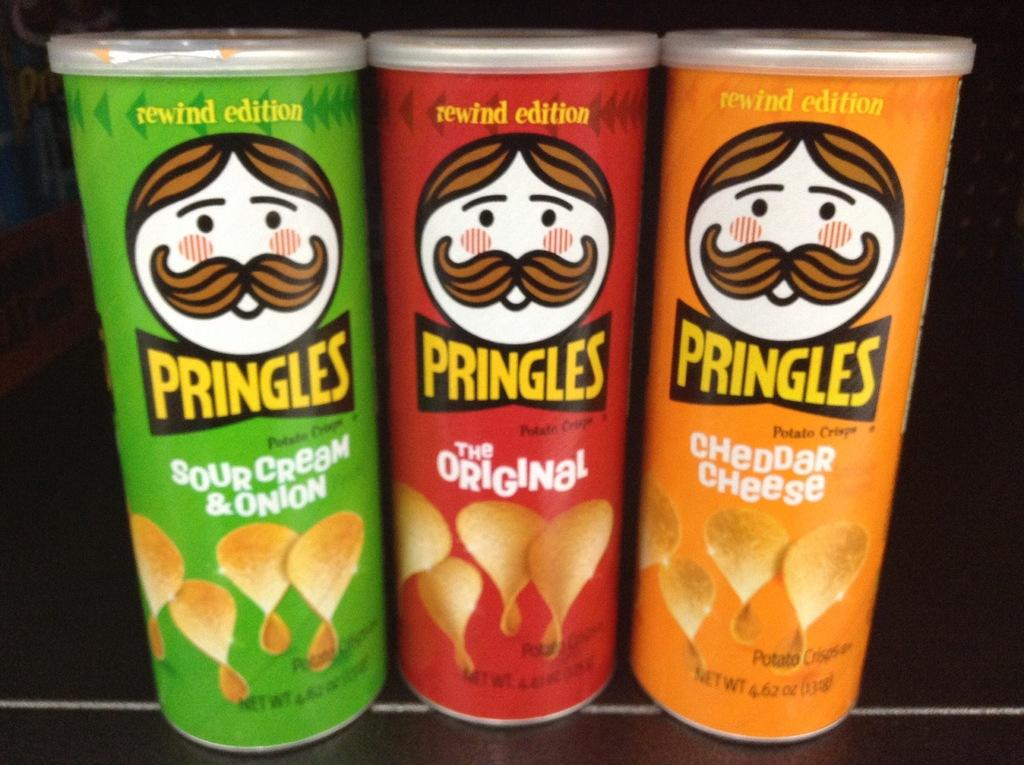How many food containers are visible in the image? There are three food containers in the image. Can you describe the appearance of the food containers? The food containers are of different colors. What type of board is being used to hold the food containers in the image? There is no board present in the image; the food containers are not being held by any visible structure. 